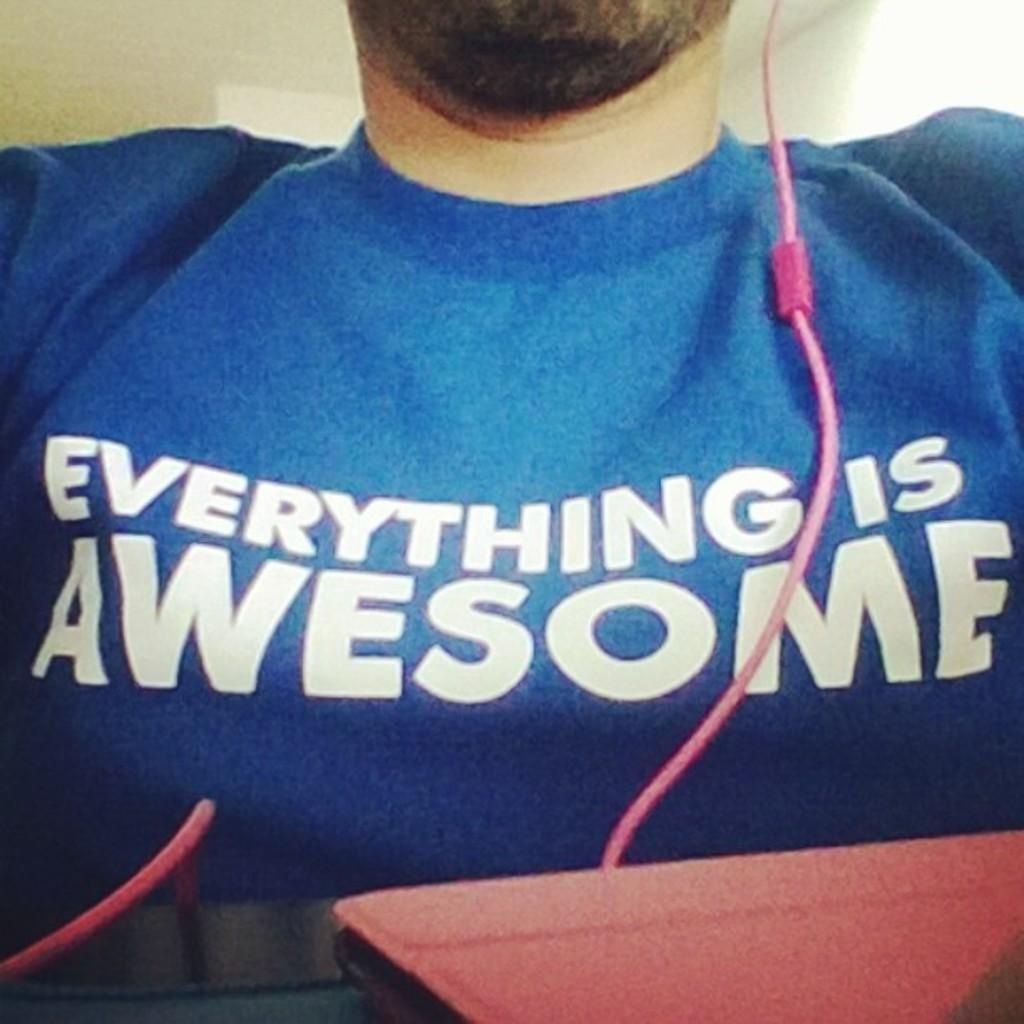<image>
Offer a succinct explanation of the picture presented. a person with a shirt on that says everything is awesome 